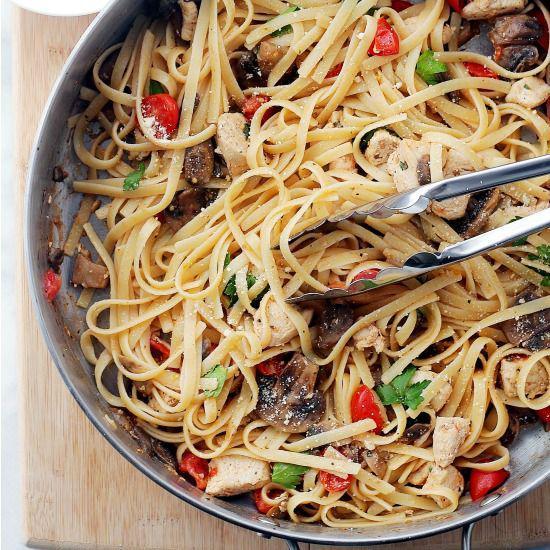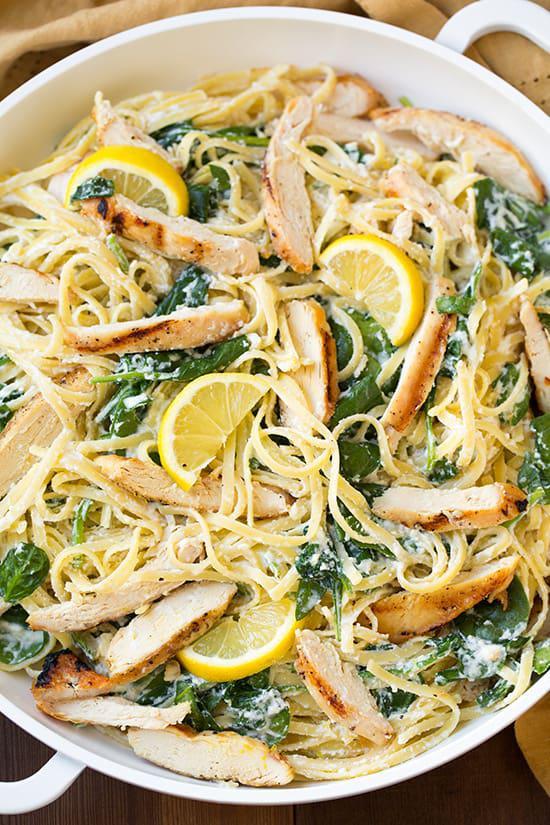The first image is the image on the left, the second image is the image on the right. Analyze the images presented: Is the assertion "One image shows a pasta dish topped with sliced lemon." valid? Answer yes or no. Yes. The first image is the image on the left, the second image is the image on the right. Examine the images to the left and right. Is the description "A silver utinsil is sitting in the bowl in one of the images." accurate? Answer yes or no. Yes. 